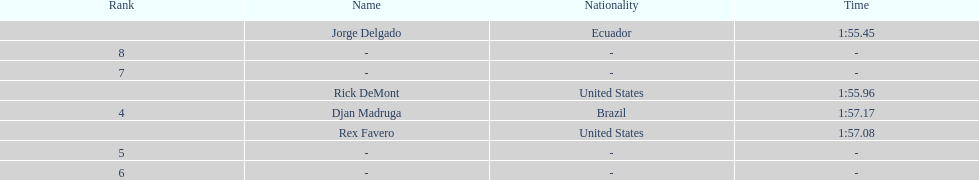What is the time for each name 1:55.45, 1:55.96, 1:57.08, 1:57.17. 